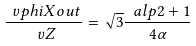Convert formula to latex. <formula><loc_0><loc_0><loc_500><loc_500>\frac { \ v p h i X o u t } { \ v Z } = \sqrt { 3 } \frac { \ a l p 2 + 1 } { 4 \alpha }</formula> 